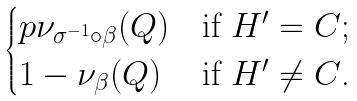Convert formula to latex. <formula><loc_0><loc_0><loc_500><loc_500>\begin{cases} p \nu _ { \sigma ^ { - 1 } \circ \beta } ( Q ) & \text {if $H^{\prime}=C$;} \\ 1 - \nu _ { \beta } ( Q ) & \text {if $H^{\prime}\neq C$.} \end{cases}</formula> 